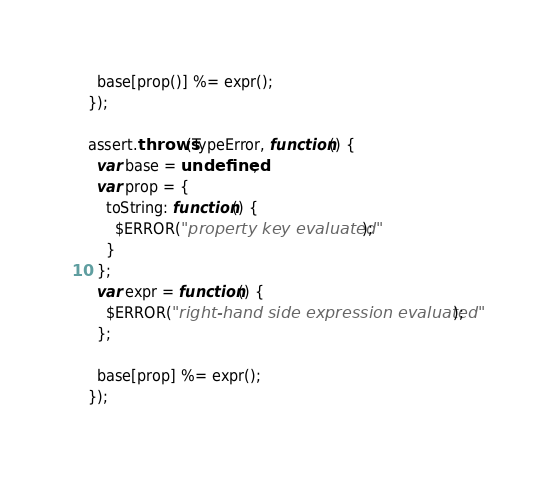<code> <loc_0><loc_0><loc_500><loc_500><_JavaScript_>  base[prop()] %= expr();
});

assert.throws(TypeError, function() {
  var base = undefined;
  var prop = {
    toString: function() {
      $ERROR("property key evaluated");
    }
  };
  var expr = function() {
    $ERROR("right-hand side expression evaluated");
  };

  base[prop] %= expr();
});
</code> 